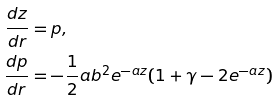<formula> <loc_0><loc_0><loc_500><loc_500>\frac { d z } { d r } & = p , \\ \frac { d p } { d r } & = - \frac { 1 } { 2 } a b ^ { 2 } e ^ { - a z } ( 1 + \gamma - 2 e ^ { - a z } )</formula> 